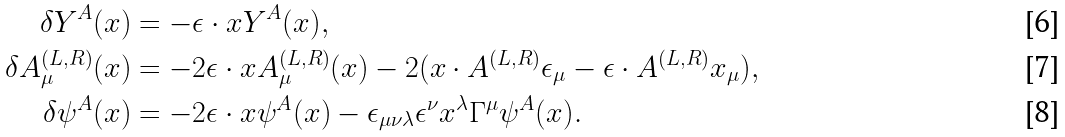Convert formula to latex. <formula><loc_0><loc_0><loc_500><loc_500>\delta Y ^ { A } ( x ) & = - \epsilon \cdot x Y ^ { A } ( x ) , \\ \delta A ^ { ( L , R ) } _ { \mu } ( x ) & = - 2 \epsilon \cdot x A ^ { ( L , R ) } _ { \mu } ( x ) - 2 ( x \cdot A ^ { ( L , R ) } \epsilon _ { \mu } - \epsilon \cdot A ^ { ( L , R ) } x _ { \mu } ) , \\ \delta \psi ^ { A } ( x ) & = - 2 \epsilon \cdot x \psi ^ { A } ( x ) - \epsilon _ { \mu \nu \lambda } \epsilon ^ { \nu } x ^ { \lambda } \Gamma ^ { \mu } \psi ^ { A } ( x ) .</formula> 